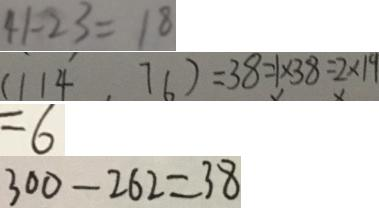<formula> <loc_0><loc_0><loc_500><loc_500>4 1 - 2 3 = 1 8 
 ( 1 1 4 , 7 6 ) = 3 8 = 1 \times 3 8 = 2 \times 1 9 
 = 6 
 3 0 0 - 2 6 2 = 3 8</formula> 